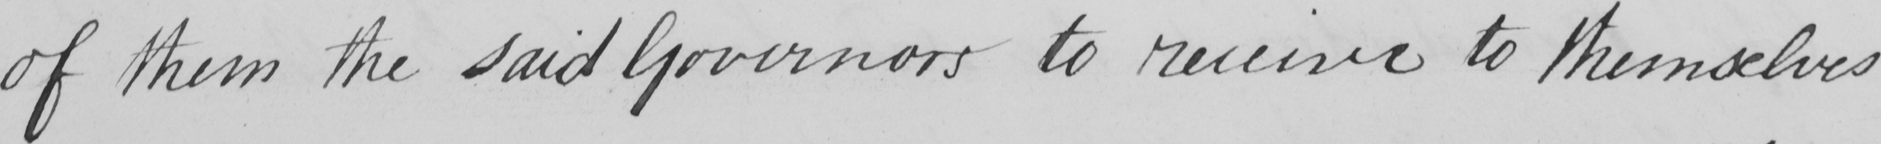Please provide the text content of this handwritten line. of them the said Governors to receive to themselves 